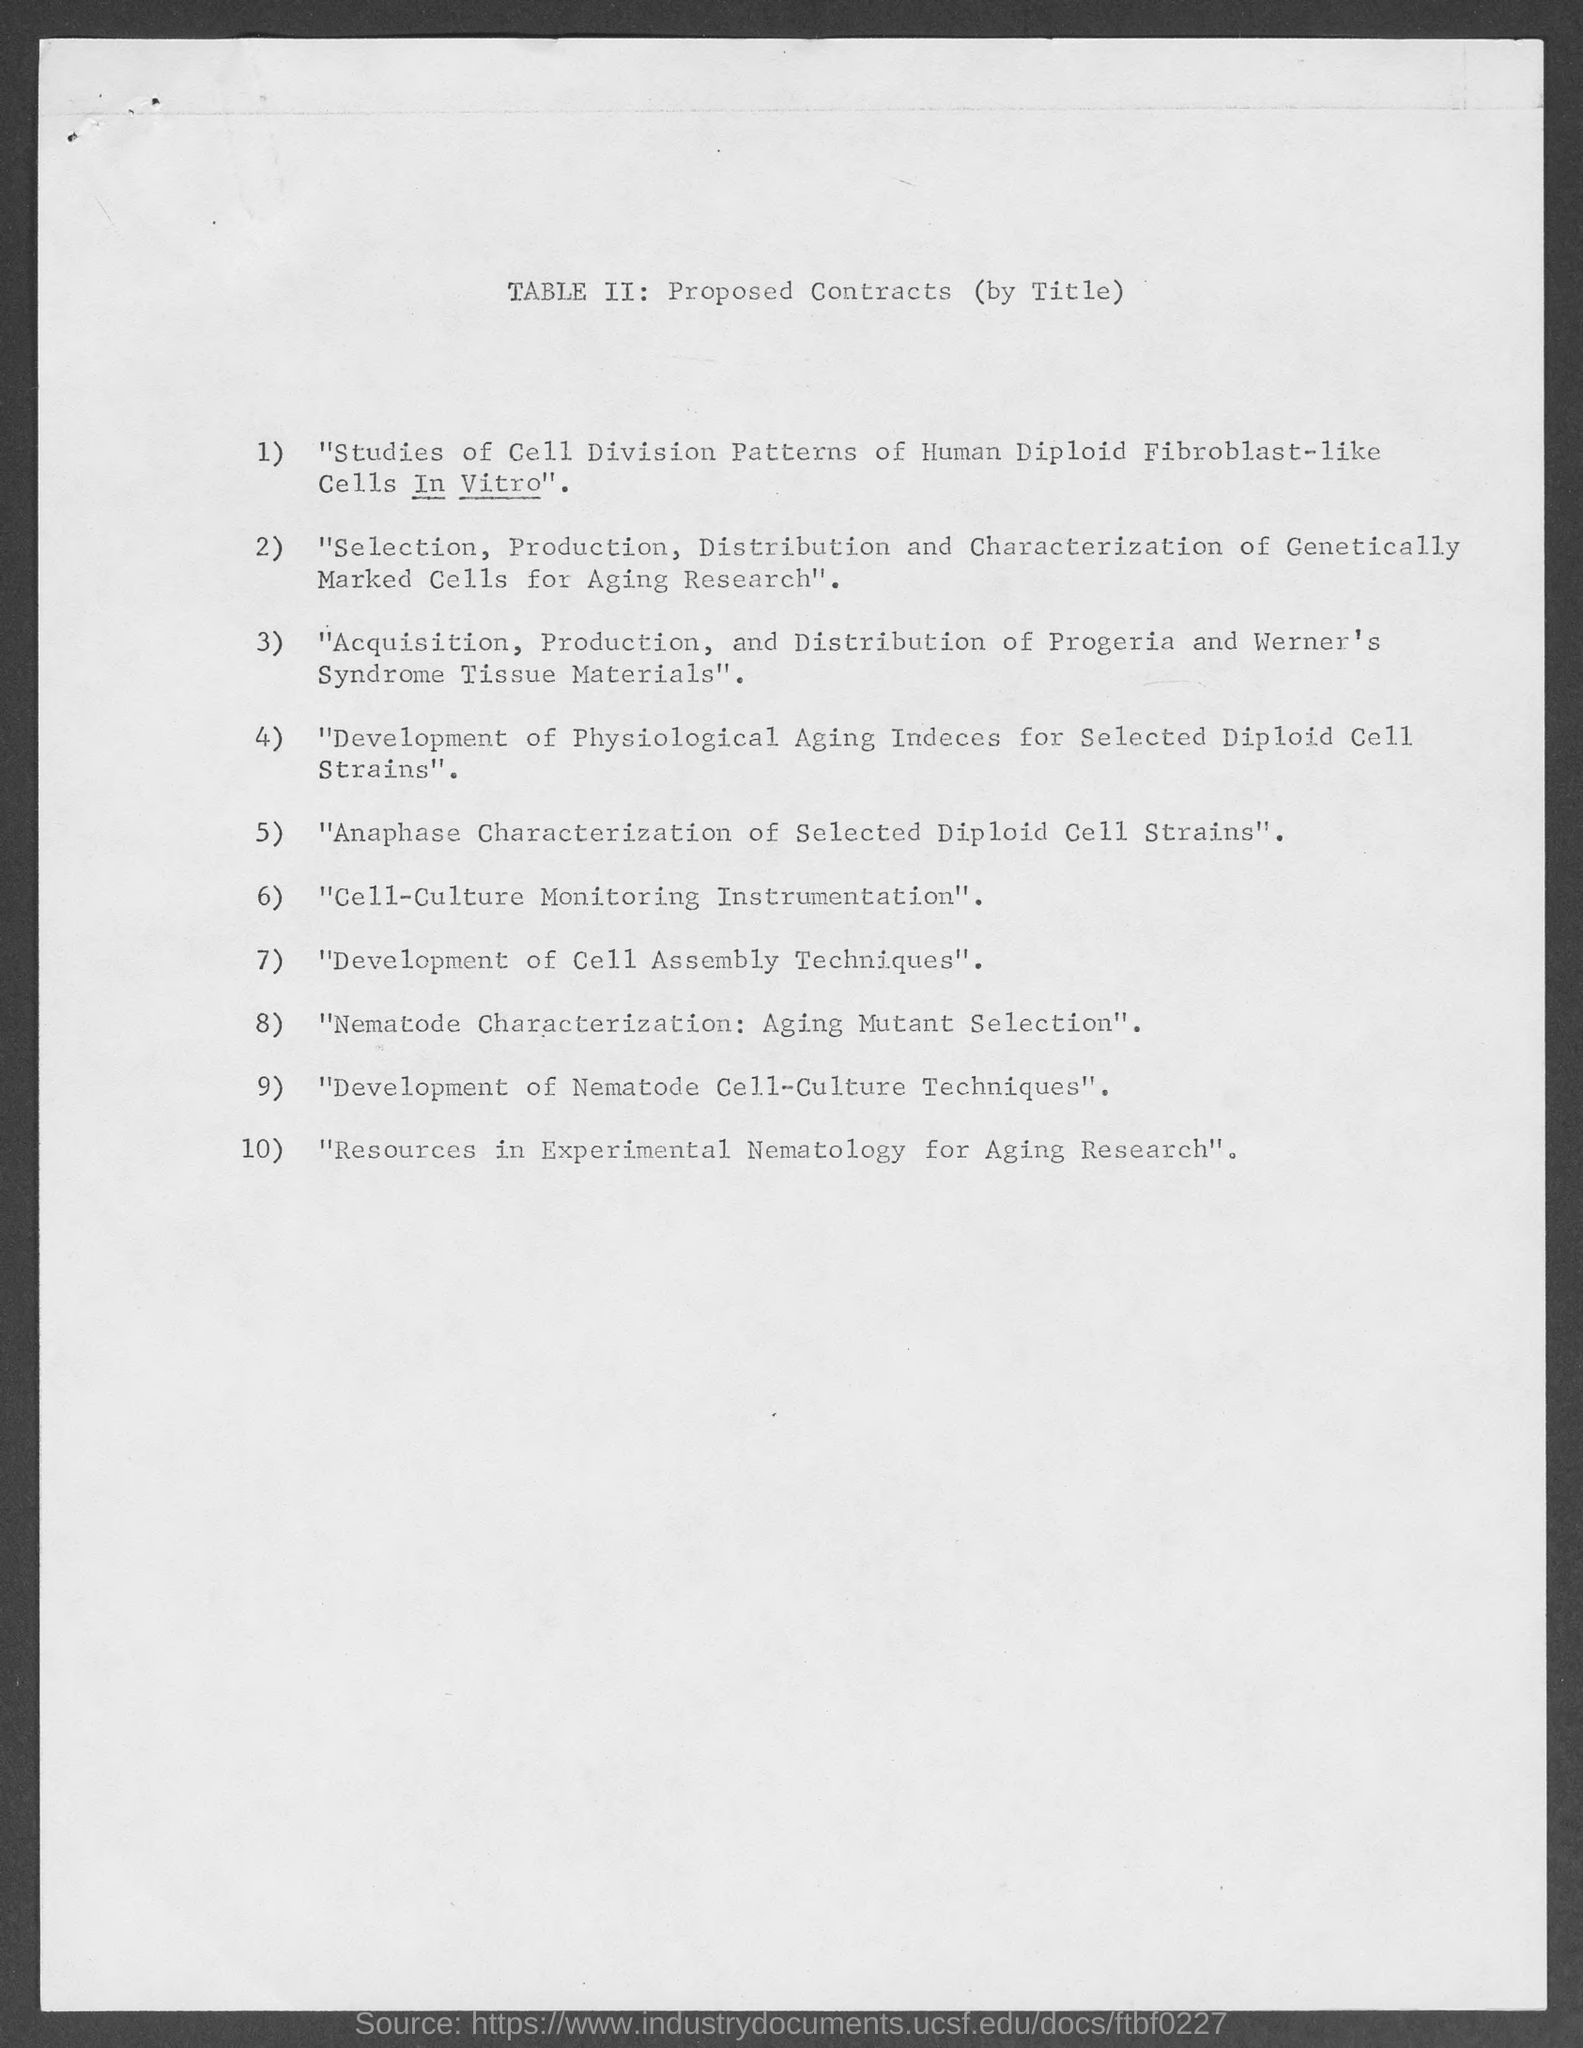What is the title of this document?
Ensure brevity in your answer.  TABLE II: Proposed Contracts (by Title). 